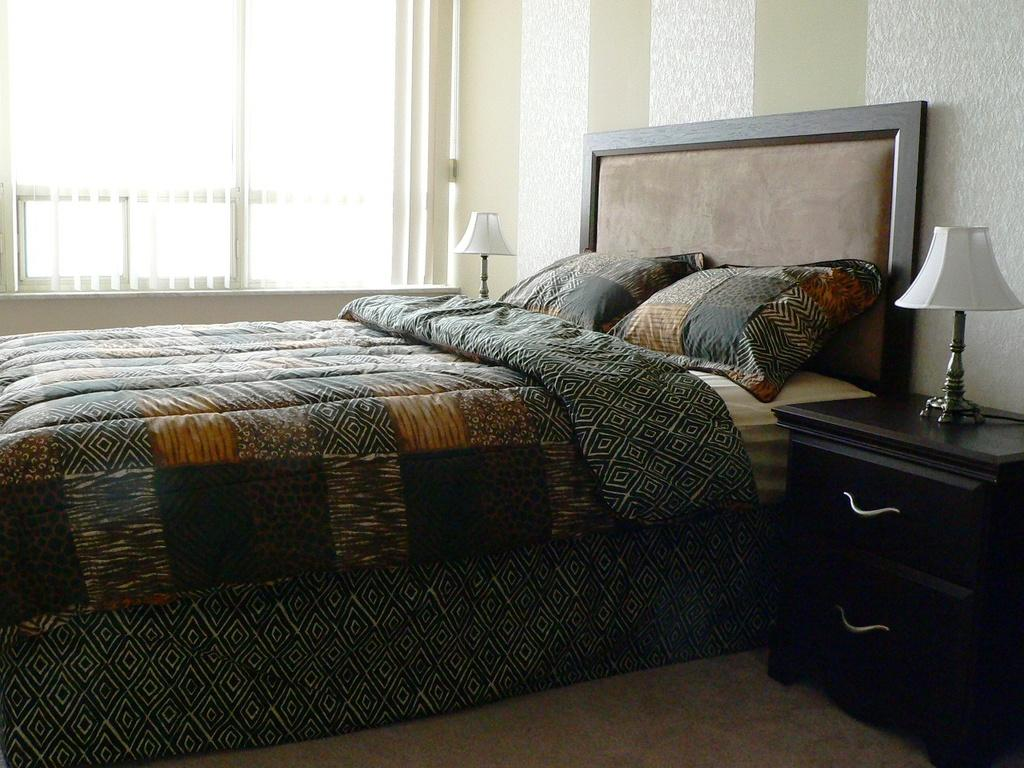What type of furniture is present in the image? There is a bed and a table in the image. What is located near the bed? There is a table near the bed. What object is on the table? There is a table lamp on the table. What color is the shirt worn by the neck in the image? There is no shirt or neck present in the image; it only features a bed, a table, and a table lamp. 